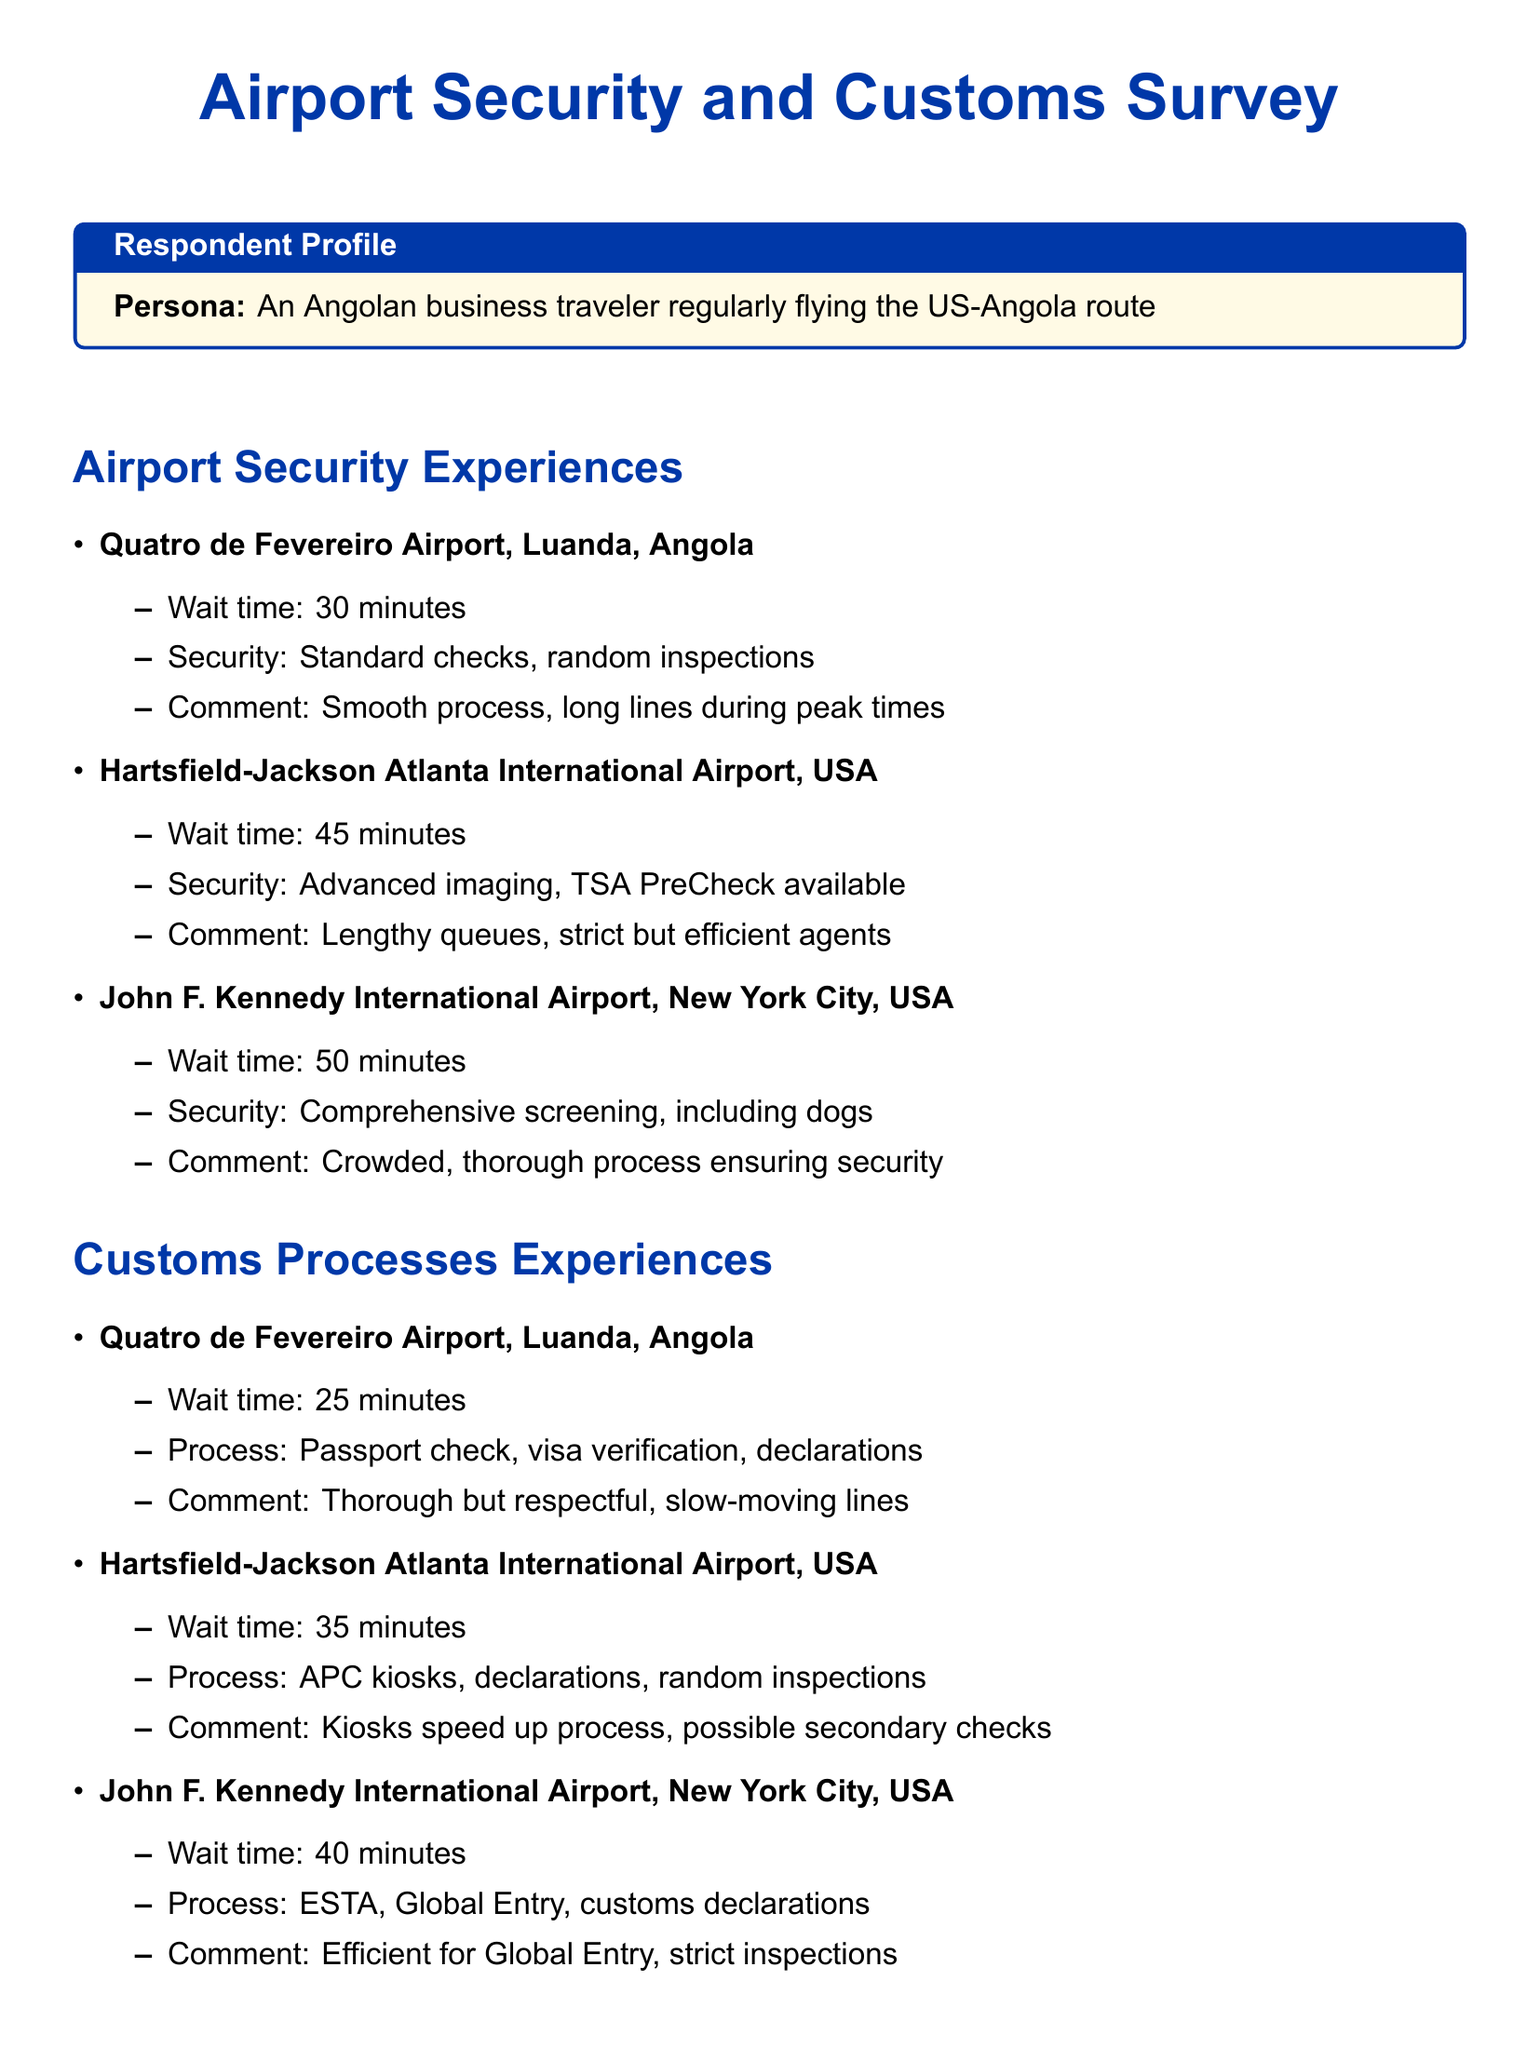what is the wait time at Quatro de Fevereiro Airport for security? The wait time for security at Quatro de Fevereiro Airport is specified in the document as 30 minutes.
Answer: 30 minutes what type of checks are performed at Hartsfield-Jackson Atlanta International Airport? The type of checks at Hartsfield-Jackson Atlanta International Airport includes advanced imaging and TSA PreCheck.
Answer: Advanced imaging, TSA PreCheck how many minutes is the customs wait time at John F. Kennedy International Airport? The document indicates that the wait time for customs at John F. Kennedy International Airport is 40 minutes.
Answer: 40 minutes what are the customs processes mentioned for Hartsfield-Jackson Atlanta International Airport? The customs processes include APC kiosks, declarations, and random inspections according to the document.
Answer: APC kiosks, declarations, random inspections which airport has a smoother security process according to the comments? The comments suggest that the Quatro de Fevereiro Airport has a smooth process despite long lines during peak times.
Answer: Quatro de Fevereiro Airport what is a challenge regarding language mentioned in the observations? The document describes a challenge of limited English proficiency in Angola as a language barrier.
Answer: Limited English what technology-related observation is made in the document? The document notes that US airports are more advanced in technology compared to Angolan airports.
Answer: US airports more advanced what is the total wait time for customs processes at the three airports combined? The total wait time is calculated as 25 (Luanda) + 35 (Atlanta) + 40 (New York) = 100 minutes.
Answer: 100 minutes 